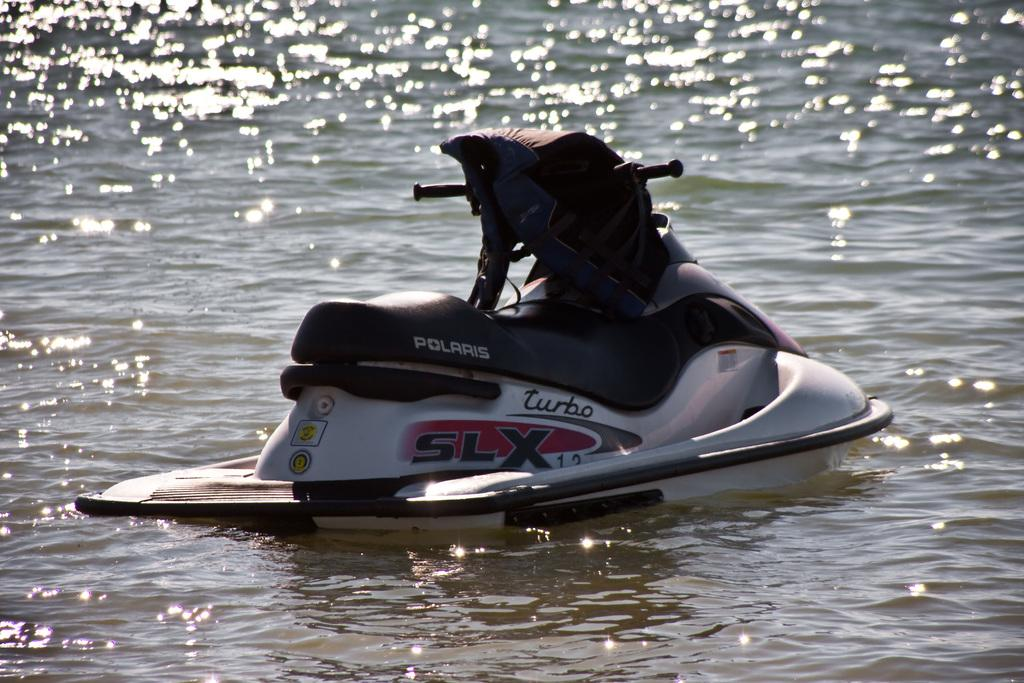What is the main subject in the image? There is a boat in the image. Can you describe the boat's position in relation to the water? The boat is above the water. What type of window can be seen on the boat in the image? There is no window visible on the boat in the image. 